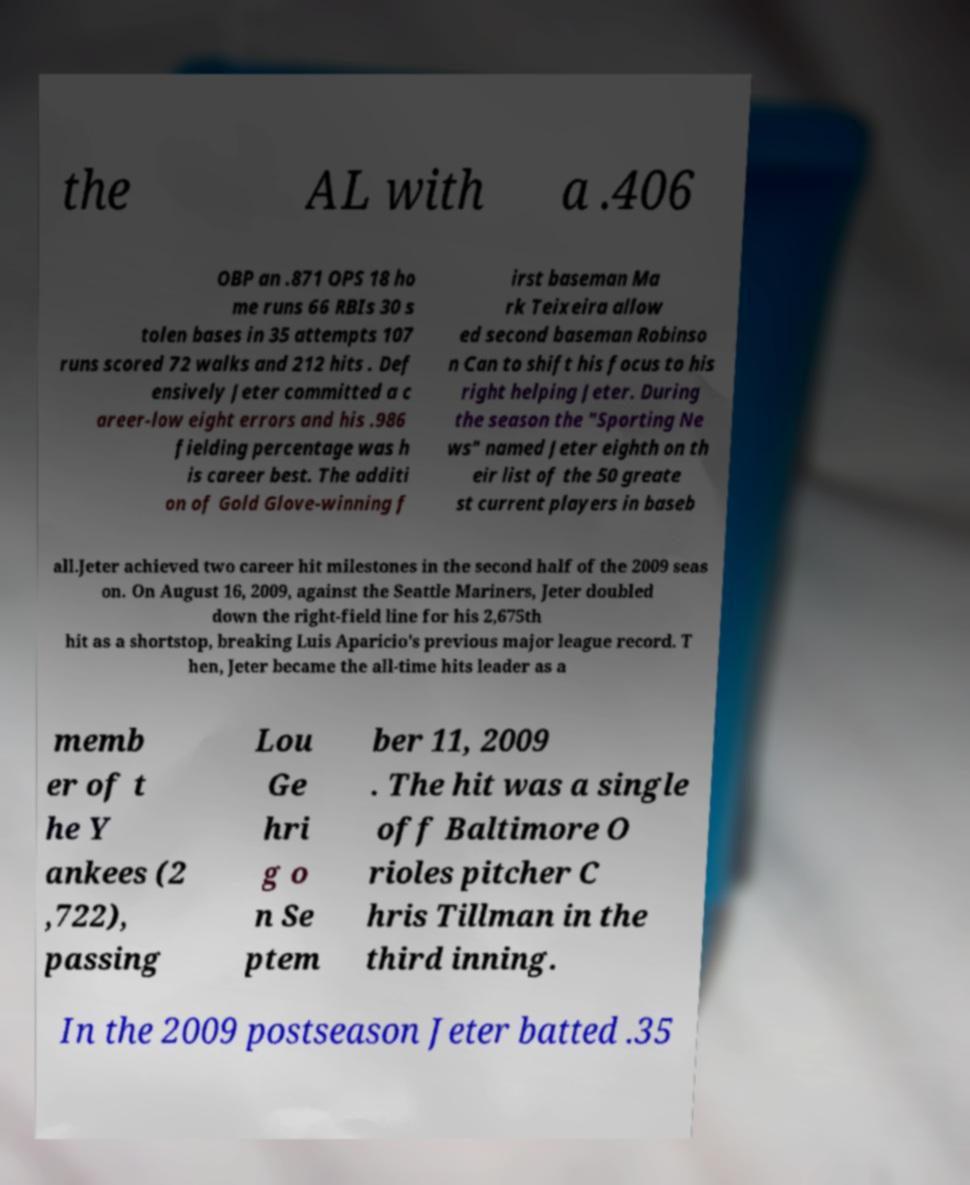Can you read and provide the text displayed in the image?This photo seems to have some interesting text. Can you extract and type it out for me? the AL with a .406 OBP an .871 OPS 18 ho me runs 66 RBIs 30 s tolen bases in 35 attempts 107 runs scored 72 walks and 212 hits . Def ensively Jeter committed a c areer-low eight errors and his .986 fielding percentage was h is career best. The additi on of Gold Glove-winning f irst baseman Ma rk Teixeira allow ed second baseman Robinso n Can to shift his focus to his right helping Jeter. During the season the "Sporting Ne ws" named Jeter eighth on th eir list of the 50 greate st current players in baseb all.Jeter achieved two career hit milestones in the second half of the 2009 seas on. On August 16, 2009, against the Seattle Mariners, Jeter doubled down the right-field line for his 2,675th hit as a shortstop, breaking Luis Aparicio's previous major league record. T hen, Jeter became the all-time hits leader as a memb er of t he Y ankees (2 ,722), passing Lou Ge hri g o n Se ptem ber 11, 2009 . The hit was a single off Baltimore O rioles pitcher C hris Tillman in the third inning. In the 2009 postseason Jeter batted .35 